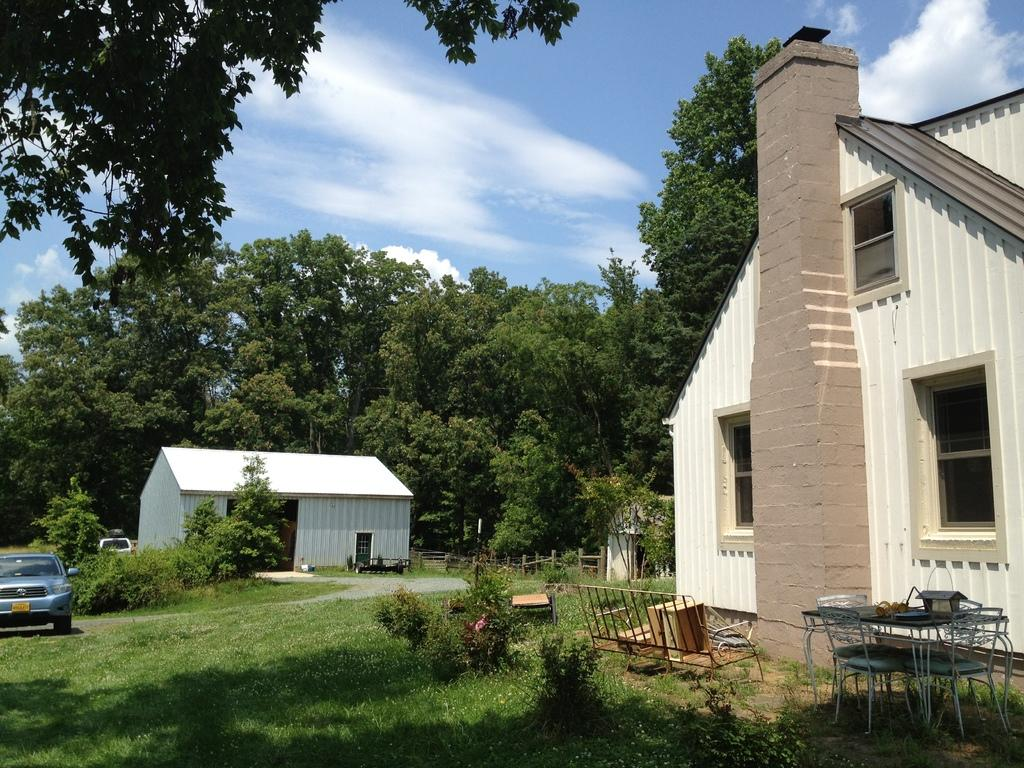What type of vegetation can be seen in the image? There is grass in the image. What type of furniture is present in the image? There are chairs and a table in the image. What else can be seen growing in the image? There are plants in the image. What else can be seen in the image besides the grass, chairs, table, and plants? There are vehicles in the image. What can be seen in the background of the image? In the background, there are houses, trees, and clouds. What type of pickle is being used as a decoration on the table in the image? There is no pickle present in the image; it is a grassy area with chairs, a table, plants, vehicles, houses, trees, and clouds in the background. 